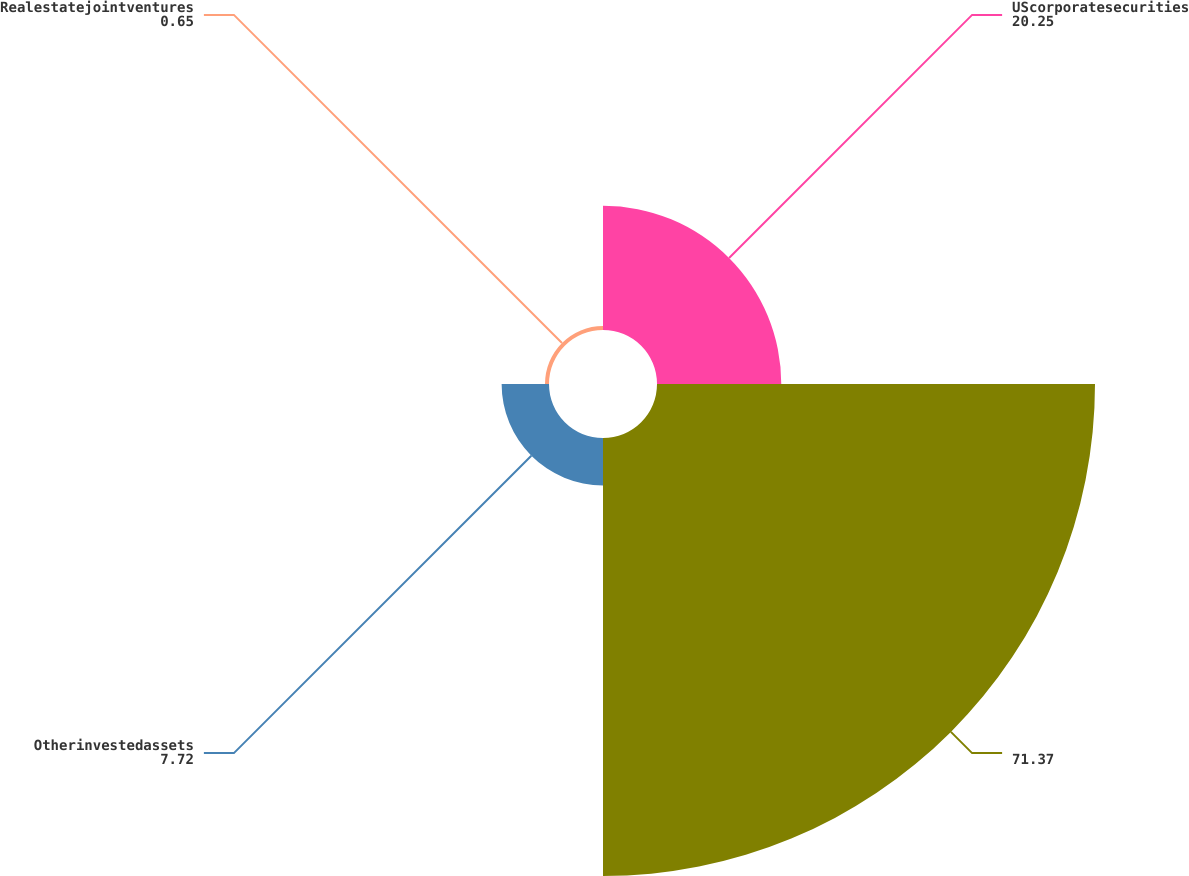Convert chart to OTSL. <chart><loc_0><loc_0><loc_500><loc_500><pie_chart><fcel>UScorporatesecurities<fcel>Unnamed: 1<fcel>Otherinvestedassets<fcel>Realestatejointventures<nl><fcel>20.25%<fcel>71.37%<fcel>7.72%<fcel>0.65%<nl></chart> 